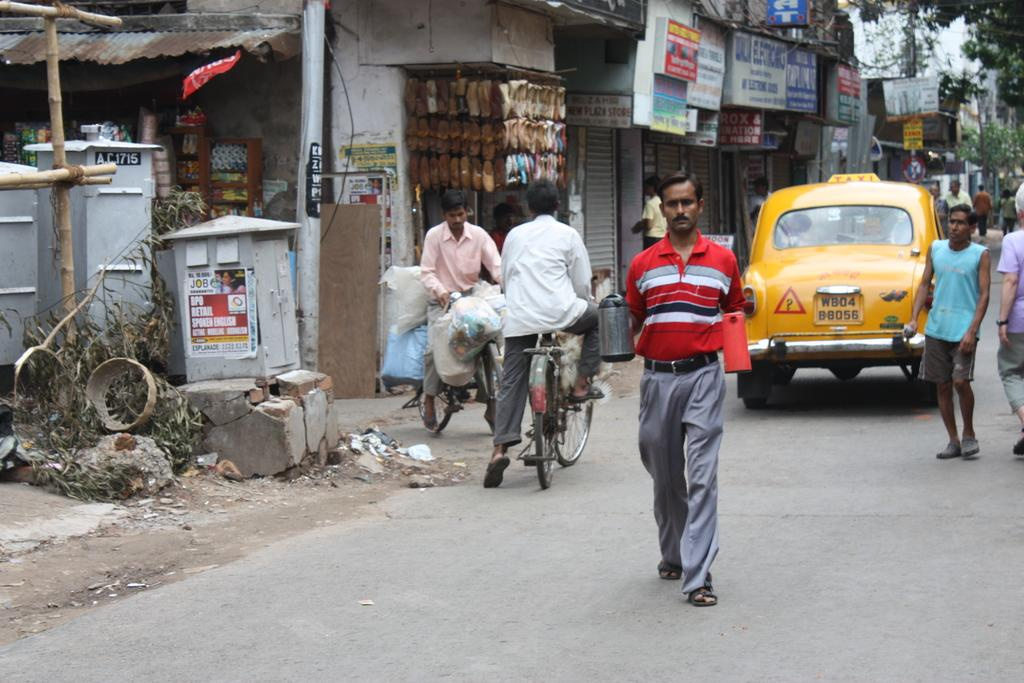What are the people in the image doing? There are persons on the road in the image, and two of them are on a bicycle. What else can be seen in the image besides the persons? There is a vehicle, a pole, a shop, and a tree in the image. Can you describe the vehicle in the image? Unfortunately, the facts provided do not give a detailed description of the vehicle. What type of establishment is the shop in the image? The facts provided do not specify the type of shop in the image. What color is the chain hanging from the tree in the image? There is no chain hanging from the tree in the image; only a pole and a tree are mentioned. 